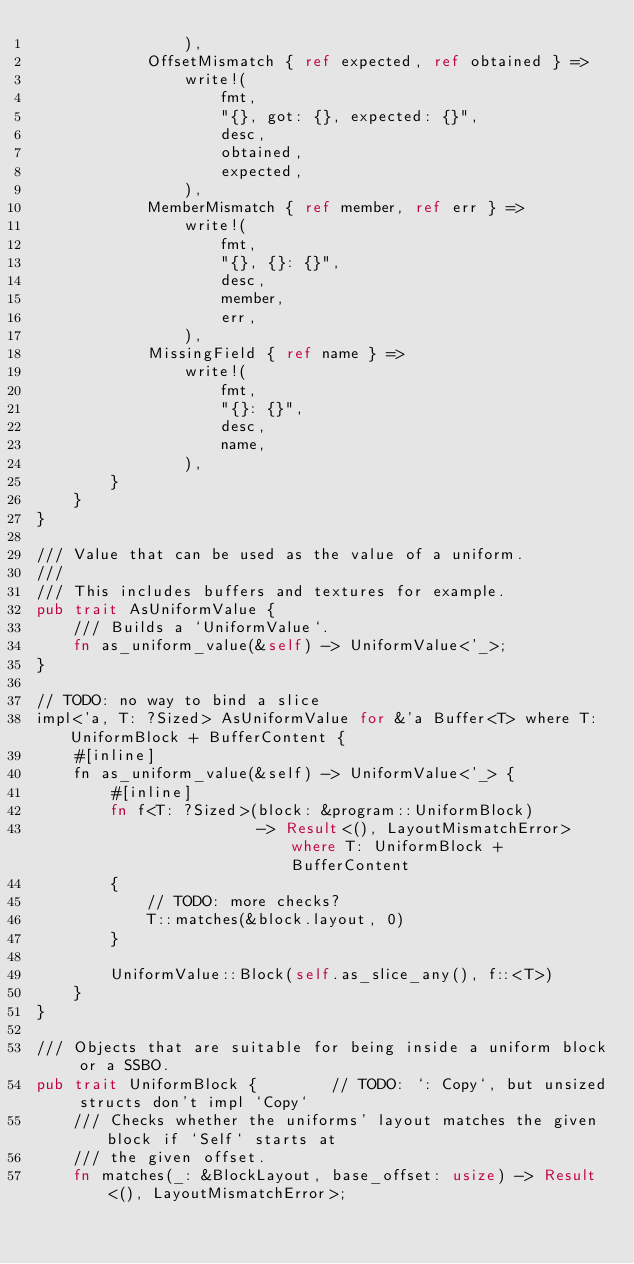<code> <loc_0><loc_0><loc_500><loc_500><_Rust_>                ),
            OffsetMismatch { ref expected, ref obtained } =>
                write!(
                    fmt,
                    "{}, got: {}, expected: {}",
                    desc,
                    obtained,
                    expected,
                ),
            MemberMismatch { ref member, ref err } =>
                write!(
                    fmt,
                    "{}, {}: {}",
                    desc,
                    member,
                    err,
                ),
            MissingField { ref name } =>
                write!(
                    fmt,
                    "{}: {}",
                    desc,
                    name,
                ),
        }
    }
}

/// Value that can be used as the value of a uniform.
///
/// This includes buffers and textures for example.
pub trait AsUniformValue {
    /// Builds a `UniformValue`.
    fn as_uniform_value(&self) -> UniformValue<'_>;
}

// TODO: no way to bind a slice
impl<'a, T: ?Sized> AsUniformValue for &'a Buffer<T> where T: UniformBlock + BufferContent {
    #[inline]
    fn as_uniform_value(&self) -> UniformValue<'_> {
        #[inline]
        fn f<T: ?Sized>(block: &program::UniformBlock)
                        -> Result<(), LayoutMismatchError> where T: UniformBlock + BufferContent
        {
            // TODO: more checks?
            T::matches(&block.layout, 0)
        }

        UniformValue::Block(self.as_slice_any(), f::<T>)
    }
}

/// Objects that are suitable for being inside a uniform block or a SSBO.
pub trait UniformBlock {        // TODO: `: Copy`, but unsized structs don't impl `Copy`
    /// Checks whether the uniforms' layout matches the given block if `Self` starts at
    /// the given offset.
    fn matches(_: &BlockLayout, base_offset: usize) -> Result<(), LayoutMismatchError>;
</code> 